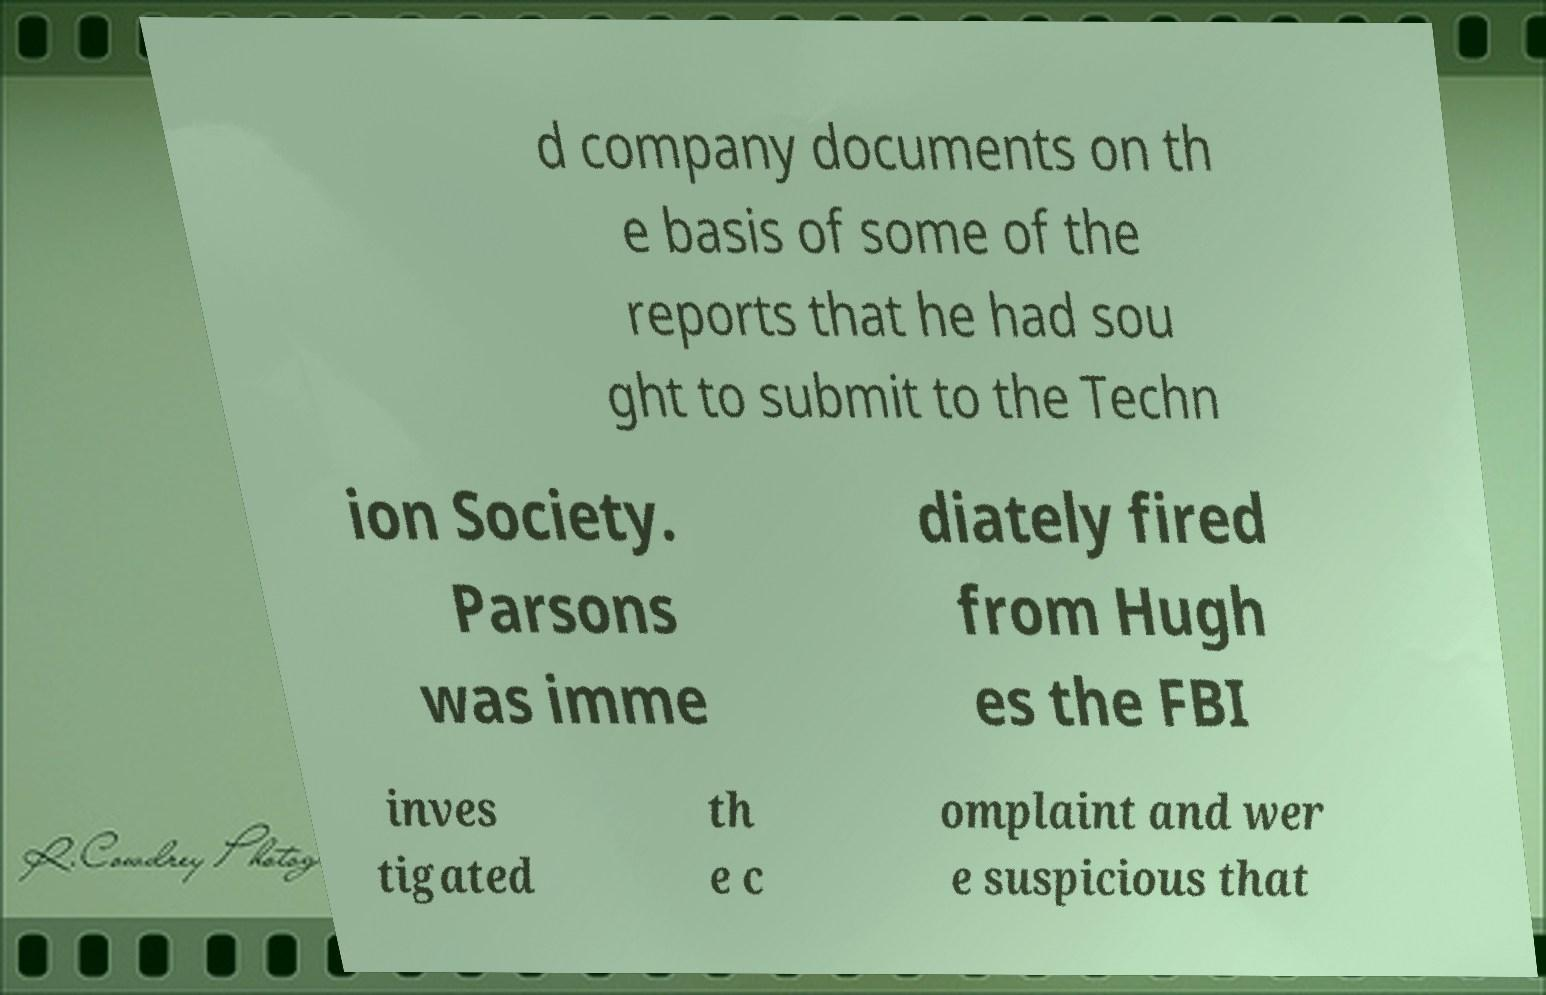For documentation purposes, I need the text within this image transcribed. Could you provide that? d company documents on th e basis of some of the reports that he had sou ght to submit to the Techn ion Society. Parsons was imme diately fired from Hugh es the FBI inves tigated th e c omplaint and wer e suspicious that 